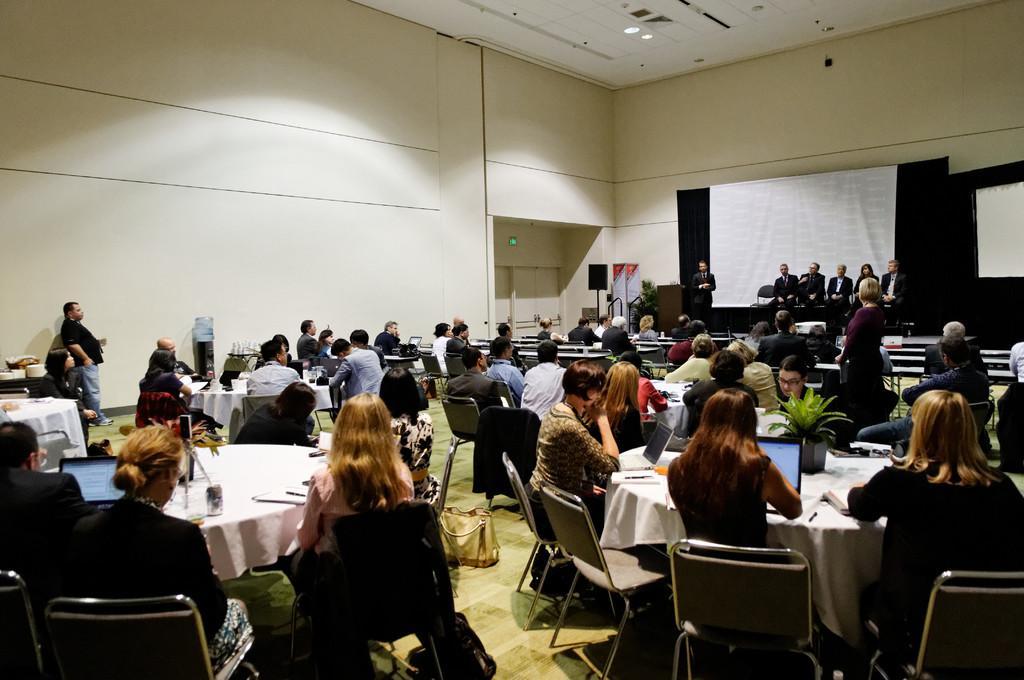Can you describe this image briefly? There are group of people sitting in the chairs and there is a table in front of them which has some objects on it and there are group of people sitting in the right corner. 